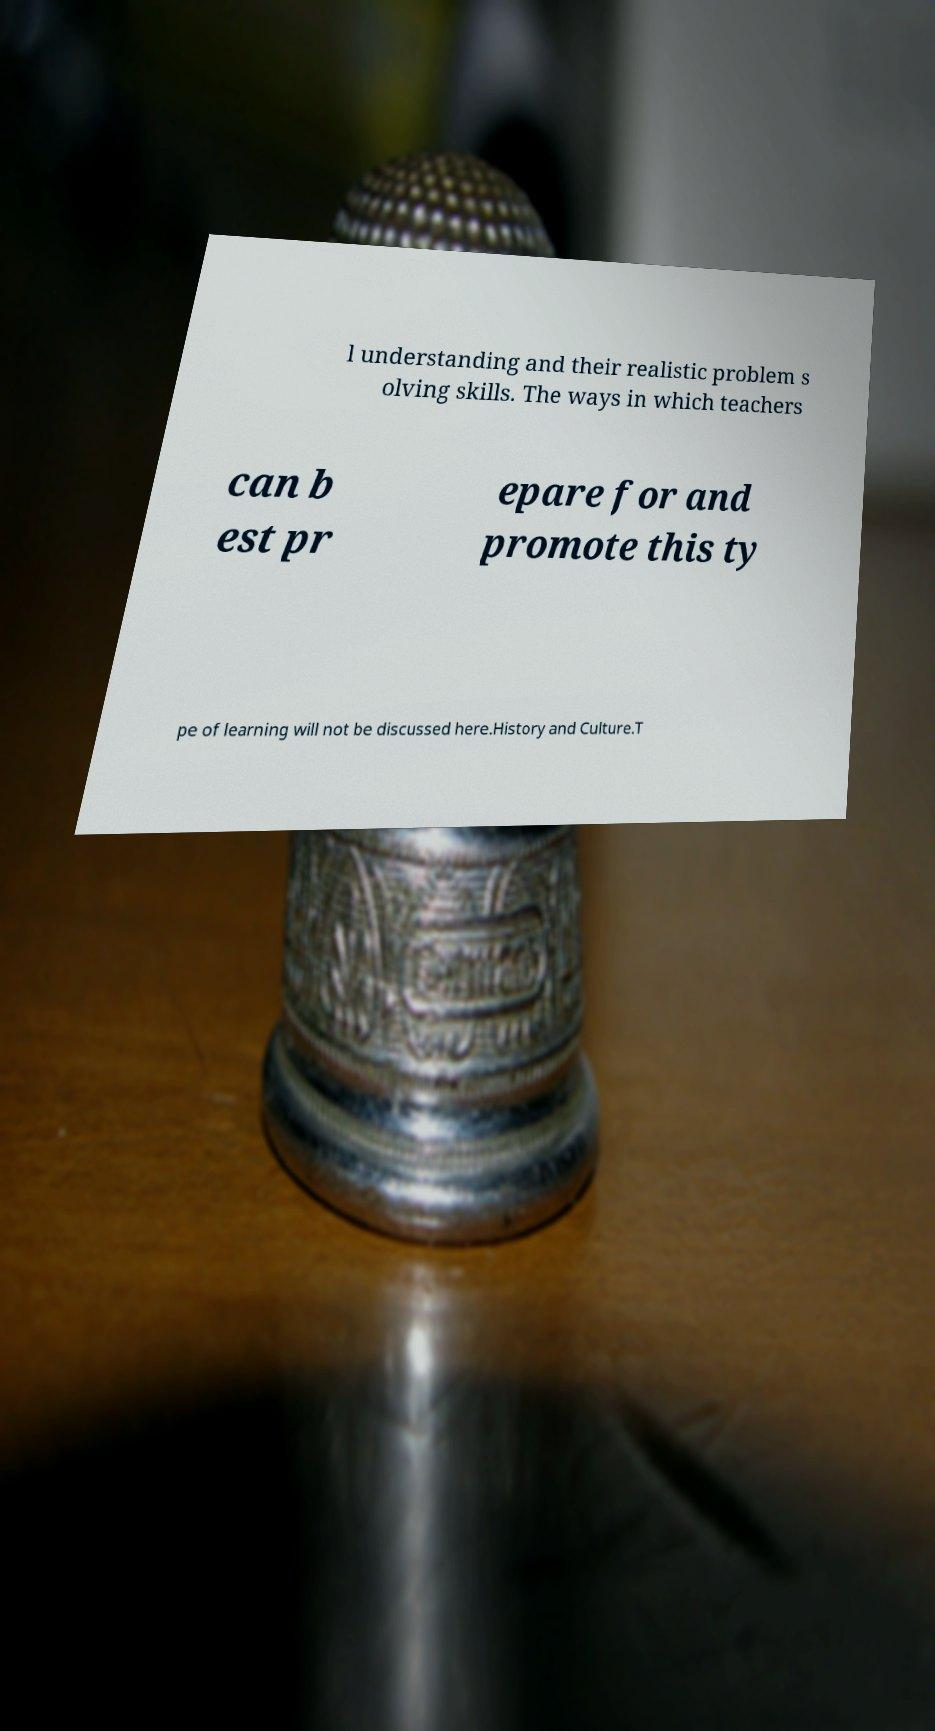I need the written content from this picture converted into text. Can you do that? l understanding and their realistic problem s olving skills. The ways in which teachers can b est pr epare for and promote this ty pe of learning will not be discussed here.History and Culture.T 